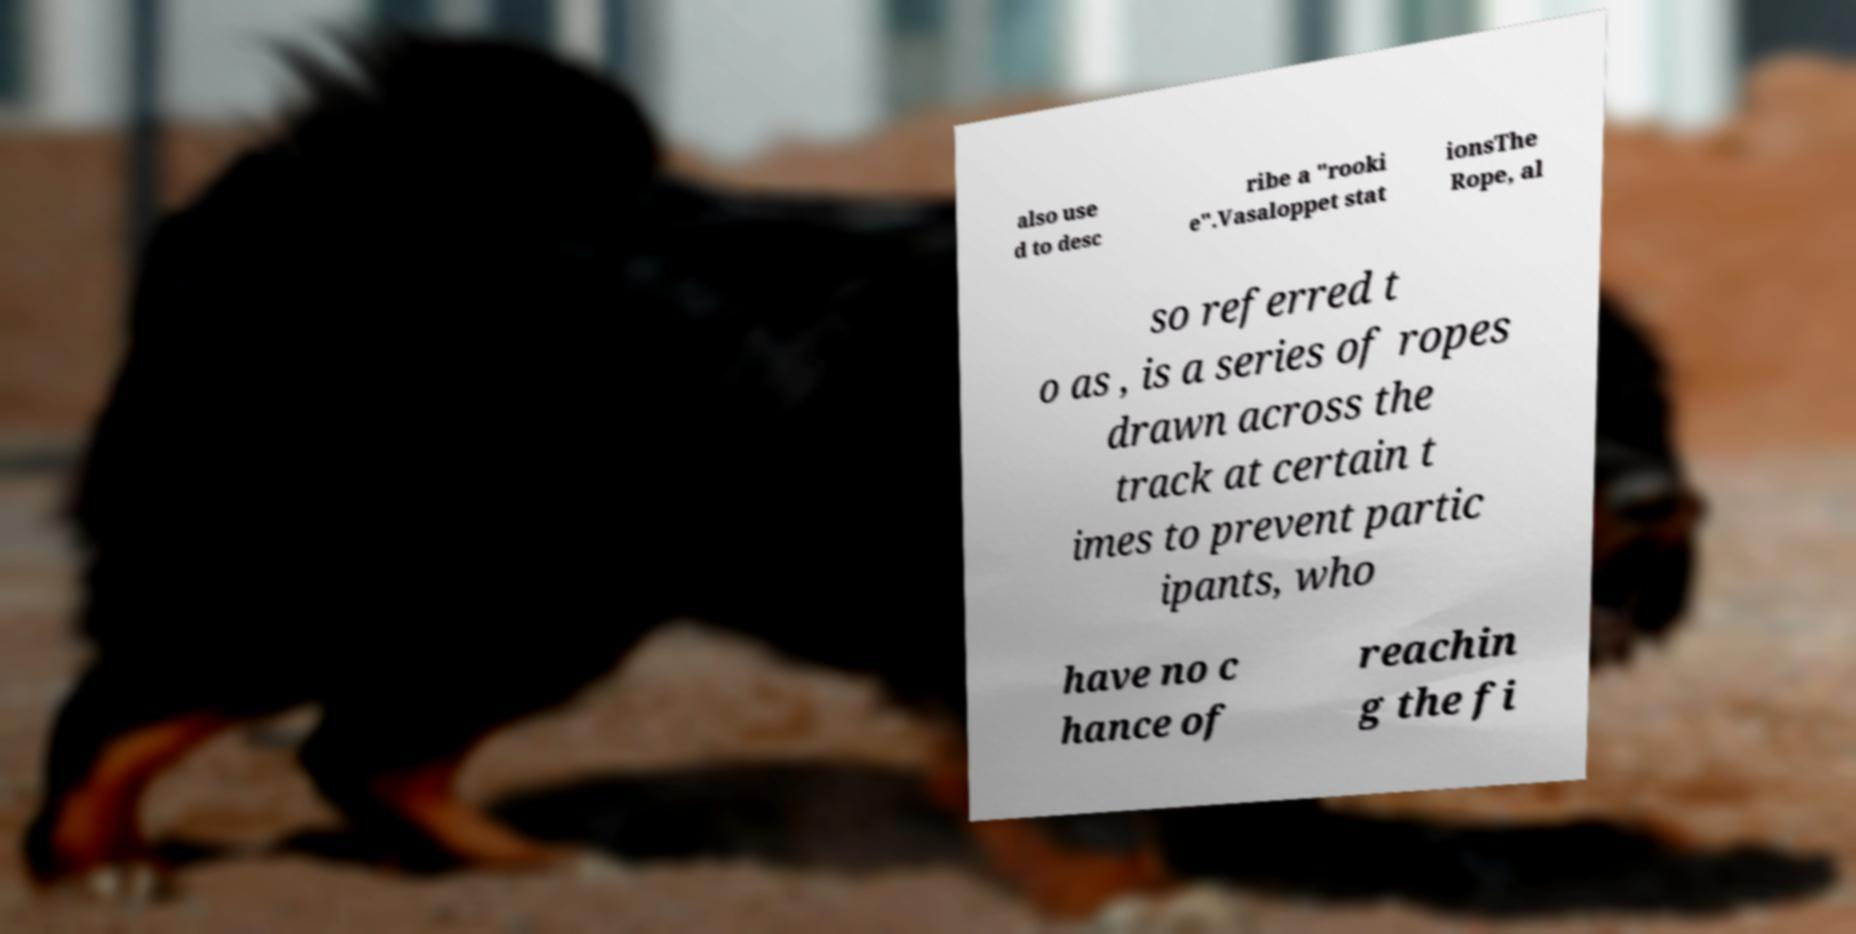I need the written content from this picture converted into text. Can you do that? also use d to desc ribe a "rooki e".Vasaloppet stat ionsThe Rope, al so referred t o as , is a series of ropes drawn across the track at certain t imes to prevent partic ipants, who have no c hance of reachin g the fi 